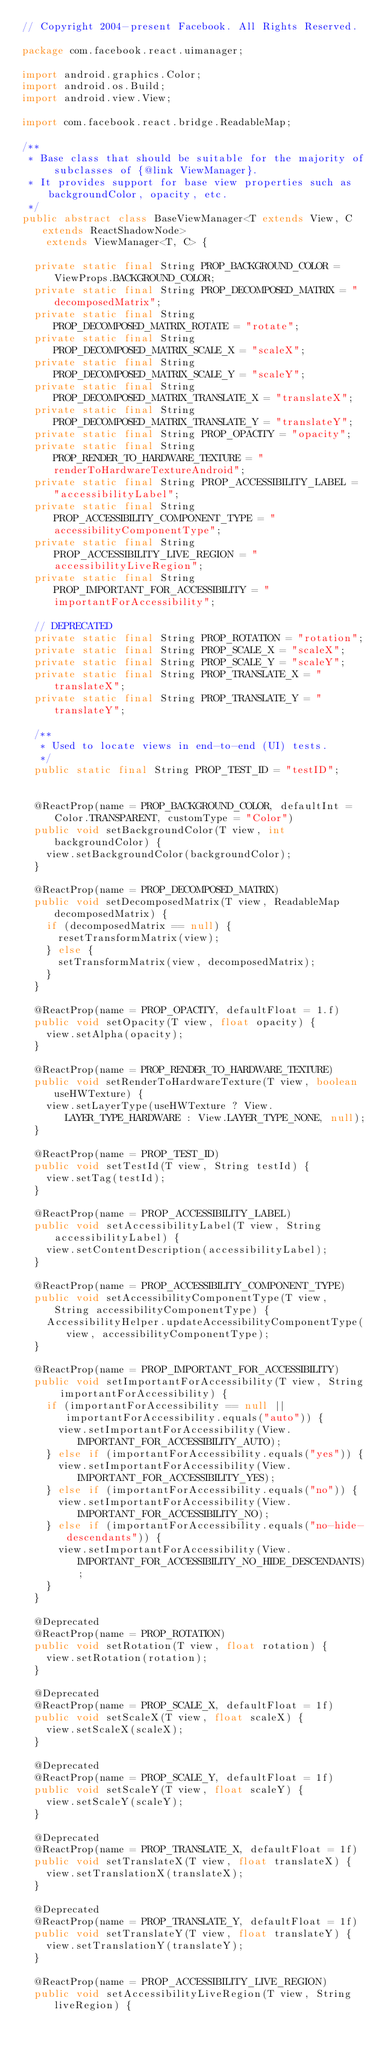Convert code to text. <code><loc_0><loc_0><loc_500><loc_500><_Java_>// Copyright 2004-present Facebook. All Rights Reserved.

package com.facebook.react.uimanager;

import android.graphics.Color;
import android.os.Build;
import android.view.View;

import com.facebook.react.bridge.ReadableMap;

/**
 * Base class that should be suitable for the majority of subclasses of {@link ViewManager}.
 * It provides support for base view properties such as backgroundColor, opacity, etc.
 */
public abstract class BaseViewManager<T extends View, C extends ReactShadowNode>
    extends ViewManager<T, C> {

  private static final String PROP_BACKGROUND_COLOR = ViewProps.BACKGROUND_COLOR;
  private static final String PROP_DECOMPOSED_MATRIX = "decomposedMatrix";
  private static final String PROP_DECOMPOSED_MATRIX_ROTATE = "rotate";
  private static final String PROP_DECOMPOSED_MATRIX_SCALE_X = "scaleX";
  private static final String PROP_DECOMPOSED_MATRIX_SCALE_Y = "scaleY";
  private static final String PROP_DECOMPOSED_MATRIX_TRANSLATE_X = "translateX";
  private static final String PROP_DECOMPOSED_MATRIX_TRANSLATE_Y = "translateY";
  private static final String PROP_OPACITY = "opacity";
  private static final String PROP_RENDER_TO_HARDWARE_TEXTURE = "renderToHardwareTextureAndroid";
  private static final String PROP_ACCESSIBILITY_LABEL = "accessibilityLabel";
  private static final String PROP_ACCESSIBILITY_COMPONENT_TYPE = "accessibilityComponentType";
  private static final String PROP_ACCESSIBILITY_LIVE_REGION = "accessibilityLiveRegion";
  private static final String PROP_IMPORTANT_FOR_ACCESSIBILITY = "importantForAccessibility";

  // DEPRECATED
  private static final String PROP_ROTATION = "rotation";
  private static final String PROP_SCALE_X = "scaleX";
  private static final String PROP_SCALE_Y = "scaleY";
  private static final String PROP_TRANSLATE_X = "translateX";
  private static final String PROP_TRANSLATE_Y = "translateY";

  /**
   * Used to locate views in end-to-end (UI) tests.
   */
  public static final String PROP_TEST_ID = "testID";


  @ReactProp(name = PROP_BACKGROUND_COLOR, defaultInt = Color.TRANSPARENT, customType = "Color")
  public void setBackgroundColor(T view, int backgroundColor) {
    view.setBackgroundColor(backgroundColor);
  }

  @ReactProp(name = PROP_DECOMPOSED_MATRIX)
  public void setDecomposedMatrix(T view, ReadableMap decomposedMatrix) {
    if (decomposedMatrix == null) {
      resetTransformMatrix(view);
    } else {
      setTransformMatrix(view, decomposedMatrix);
    }
  }

  @ReactProp(name = PROP_OPACITY, defaultFloat = 1.f)
  public void setOpacity(T view, float opacity) {
    view.setAlpha(opacity);
  }

  @ReactProp(name = PROP_RENDER_TO_HARDWARE_TEXTURE)
  public void setRenderToHardwareTexture(T view, boolean useHWTexture) {
    view.setLayerType(useHWTexture ? View.LAYER_TYPE_HARDWARE : View.LAYER_TYPE_NONE, null);
  }

  @ReactProp(name = PROP_TEST_ID)
  public void setTestId(T view, String testId) {
    view.setTag(testId);
  }

  @ReactProp(name = PROP_ACCESSIBILITY_LABEL)
  public void setAccessibilityLabel(T view, String accessibilityLabel) {
    view.setContentDescription(accessibilityLabel);
  }

  @ReactProp(name = PROP_ACCESSIBILITY_COMPONENT_TYPE)
  public void setAccessibilityComponentType(T view, String accessibilityComponentType) {
    AccessibilityHelper.updateAccessibilityComponentType(view, accessibilityComponentType);
  }

  @ReactProp(name = PROP_IMPORTANT_FOR_ACCESSIBILITY)
  public void setImportantForAccessibility(T view, String importantForAccessibility) {
    if (importantForAccessibility == null || importantForAccessibility.equals("auto")) {
      view.setImportantForAccessibility(View.IMPORTANT_FOR_ACCESSIBILITY_AUTO);
    } else if (importantForAccessibility.equals("yes")) {
      view.setImportantForAccessibility(View.IMPORTANT_FOR_ACCESSIBILITY_YES);
    } else if (importantForAccessibility.equals("no")) {
      view.setImportantForAccessibility(View.IMPORTANT_FOR_ACCESSIBILITY_NO);
    } else if (importantForAccessibility.equals("no-hide-descendants")) {
      view.setImportantForAccessibility(View.IMPORTANT_FOR_ACCESSIBILITY_NO_HIDE_DESCENDANTS);
    }
  }

  @Deprecated
  @ReactProp(name = PROP_ROTATION)
  public void setRotation(T view, float rotation) {
    view.setRotation(rotation);
  }

  @Deprecated
  @ReactProp(name = PROP_SCALE_X, defaultFloat = 1f)
  public void setScaleX(T view, float scaleX) {
    view.setScaleX(scaleX);
  }

  @Deprecated
  @ReactProp(name = PROP_SCALE_Y, defaultFloat = 1f)
  public void setScaleY(T view, float scaleY) {
    view.setScaleY(scaleY);
  }

  @Deprecated
  @ReactProp(name = PROP_TRANSLATE_X, defaultFloat = 1f)
  public void setTranslateX(T view, float translateX) {
    view.setTranslationX(translateX);
  }

  @Deprecated
  @ReactProp(name = PROP_TRANSLATE_Y, defaultFloat = 1f)
  public void setTranslateY(T view, float translateY) {
    view.setTranslationY(translateY);
  }

  @ReactProp(name = PROP_ACCESSIBILITY_LIVE_REGION)
  public void setAccessibilityLiveRegion(T view, String liveRegion) {</code> 